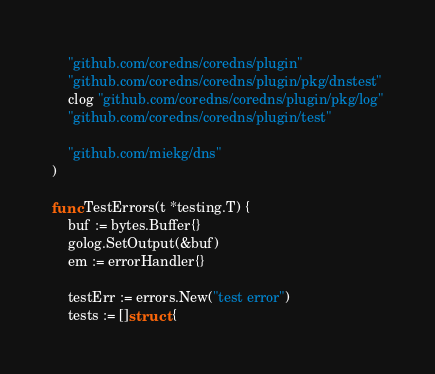<code> <loc_0><loc_0><loc_500><loc_500><_Go_>
	"github.com/coredns/coredns/plugin"
	"github.com/coredns/coredns/plugin/pkg/dnstest"
	clog "github.com/coredns/coredns/plugin/pkg/log"
	"github.com/coredns/coredns/plugin/test"

	"github.com/miekg/dns"
)

func TestErrors(t *testing.T) {
	buf := bytes.Buffer{}
	golog.SetOutput(&buf)
	em := errorHandler{}

	testErr := errors.New("test error")
	tests := []struct {</code> 